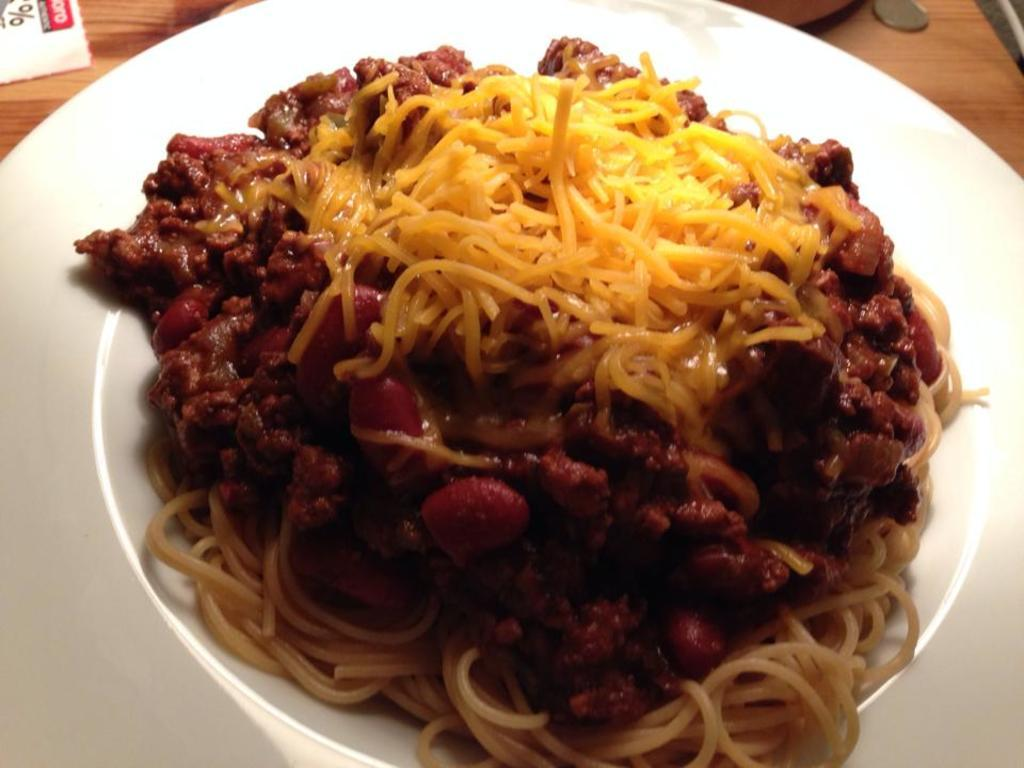What is in the bowl that is visible in the image? There is a food item in a bowl in the image. How is the bowl positioned on the plate? The bowl is on top of a plate in the image. Where is the plate located? The plate is on a table in the image. What can be seen beside the plate? There are objects beside the plate in the image. What type of quartz can be seen beside the plate in the image? There is no quartz present in the image. Is there a boot visible beside the plate in the image? No, there is no boot visible beside the plate in the image. 